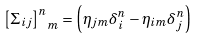Convert formula to latex. <formula><loc_0><loc_0><loc_500><loc_500>\left [ \Sigma _ { i j } \right ] _ { \ m } ^ { n } = \left ( \eta _ { j m } \delta ^ { n } _ { i } - \eta _ { i m } \delta ^ { n } _ { j } \right )</formula> 